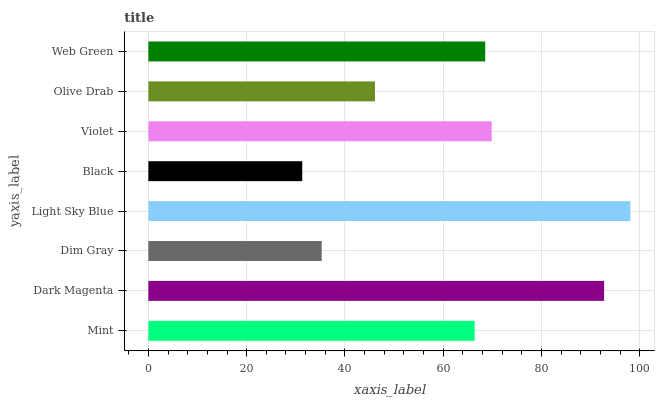Is Black the minimum?
Answer yes or no. Yes. Is Light Sky Blue the maximum?
Answer yes or no. Yes. Is Dark Magenta the minimum?
Answer yes or no. No. Is Dark Magenta the maximum?
Answer yes or no. No. Is Dark Magenta greater than Mint?
Answer yes or no. Yes. Is Mint less than Dark Magenta?
Answer yes or no. Yes. Is Mint greater than Dark Magenta?
Answer yes or no. No. Is Dark Magenta less than Mint?
Answer yes or no. No. Is Web Green the high median?
Answer yes or no. Yes. Is Mint the low median?
Answer yes or no. Yes. Is Black the high median?
Answer yes or no. No. Is Web Green the low median?
Answer yes or no. No. 